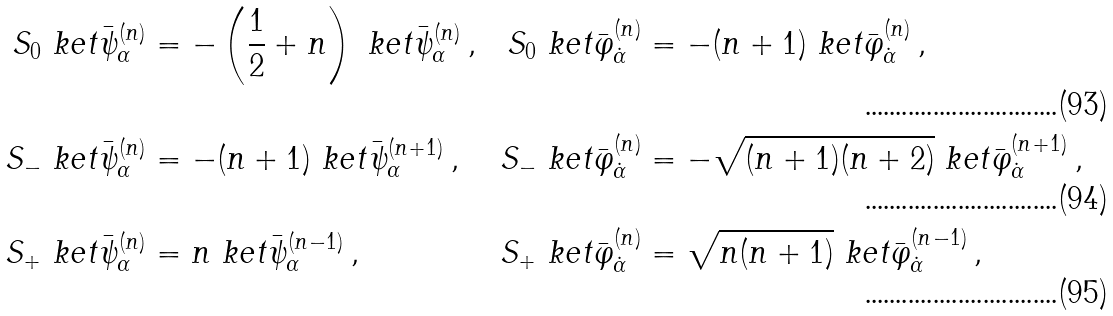<formula> <loc_0><loc_0><loc_500><loc_500>S _ { 0 } \ k e t { \bar { \psi } _ { \alpha } ^ { ( n ) } } & = - \left ( \frac { 1 } { 2 } + n \right ) \ k e t { \bar { \psi } _ { \alpha } ^ { ( n ) } } \, , & S _ { 0 } \ k e t { \bar { \varphi } _ { \dot { \alpha } } ^ { ( n ) } } & = - ( n + 1 ) \ k e t { \bar { \varphi } _ { \dot { \alpha } } ^ { ( n ) } } \, , \\ S _ { - } \ k e t { \bar { \psi } _ { \alpha } ^ { ( n ) } } & = - ( n + 1 ) \ k e t { \bar { \psi } _ { \alpha } ^ { ( n + 1 ) } } \, , & S _ { - } \ k e t { \bar { \varphi } _ { \dot { \alpha } } ^ { ( n ) } } & = - \sqrt { ( n + 1 ) ( n + 2 ) } \ k e t { \bar { \varphi } _ { \dot { \alpha } } ^ { ( n + 1 ) } } \, , \\ S _ { + } \ k e t { \bar { \psi } _ { \alpha } ^ { ( n ) } } & = n \ k e t { \bar { \psi } _ { \alpha } ^ { ( n - 1 ) } } \, , & S _ { + } \ k e t { \bar { \varphi } _ { \dot { \alpha } } ^ { ( n ) } } & = \sqrt { n ( n + 1 ) } \ k e t { \bar { \varphi } _ { \dot { \alpha } } ^ { ( n - 1 ) } } \, ,</formula> 